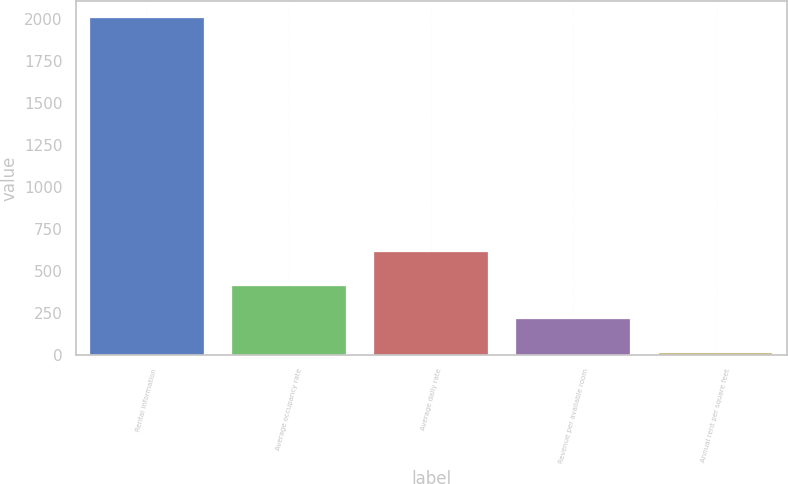Convert chart to OTSL. <chart><loc_0><loc_0><loc_500><loc_500><bar_chart><fcel>Rental information<fcel>Average occupancy rate<fcel>Average daily rate<fcel>Revenue per available room<fcel>Annual rent per square feet<nl><fcel>2003<fcel>408.54<fcel>607.85<fcel>209.23<fcel>9.92<nl></chart> 